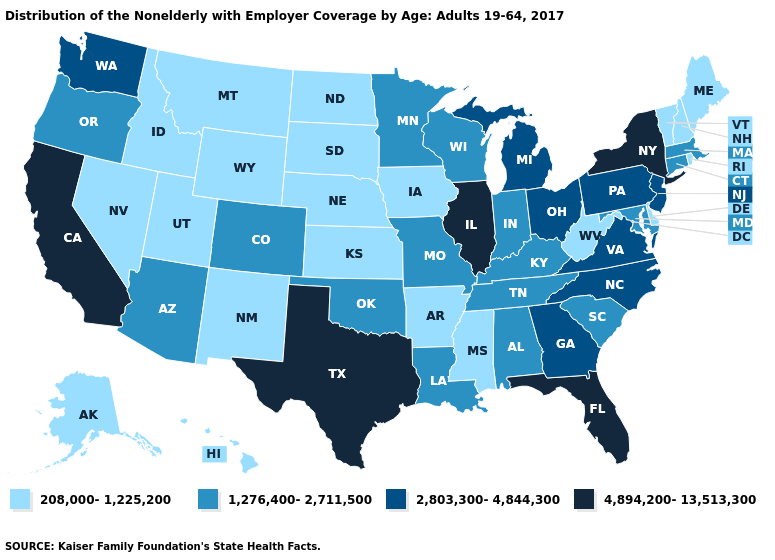Does Washington have the lowest value in the USA?
Write a very short answer. No. What is the lowest value in the Northeast?
Short answer required. 208,000-1,225,200. Among the states that border Iowa , does Wisconsin have the highest value?
Be succinct. No. Among the states that border Arkansas , which have the lowest value?
Concise answer only. Mississippi. Name the states that have a value in the range 208,000-1,225,200?
Be succinct. Alaska, Arkansas, Delaware, Hawaii, Idaho, Iowa, Kansas, Maine, Mississippi, Montana, Nebraska, Nevada, New Hampshire, New Mexico, North Dakota, Rhode Island, South Dakota, Utah, Vermont, West Virginia, Wyoming. Which states hav the highest value in the Northeast?
Short answer required. New York. Does New Hampshire have the lowest value in the USA?
Write a very short answer. Yes. What is the value of Ohio?
Be succinct. 2,803,300-4,844,300. Name the states that have a value in the range 2,803,300-4,844,300?
Write a very short answer. Georgia, Michigan, New Jersey, North Carolina, Ohio, Pennsylvania, Virginia, Washington. What is the highest value in the South ?
Short answer required. 4,894,200-13,513,300. What is the highest value in the Northeast ?
Short answer required. 4,894,200-13,513,300. Name the states that have a value in the range 2,803,300-4,844,300?
Write a very short answer. Georgia, Michigan, New Jersey, North Carolina, Ohio, Pennsylvania, Virginia, Washington. Among the states that border West Virginia , does Virginia have the highest value?
Answer briefly. Yes. What is the value of Alaska?
Concise answer only. 208,000-1,225,200. Which states have the lowest value in the South?
Keep it brief. Arkansas, Delaware, Mississippi, West Virginia. 